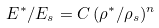<formula> <loc_0><loc_0><loc_500><loc_500>E ^ { * } / E _ { s } = C \, ( \rho ^ { * } / \rho _ { s } ) ^ { n }</formula> 